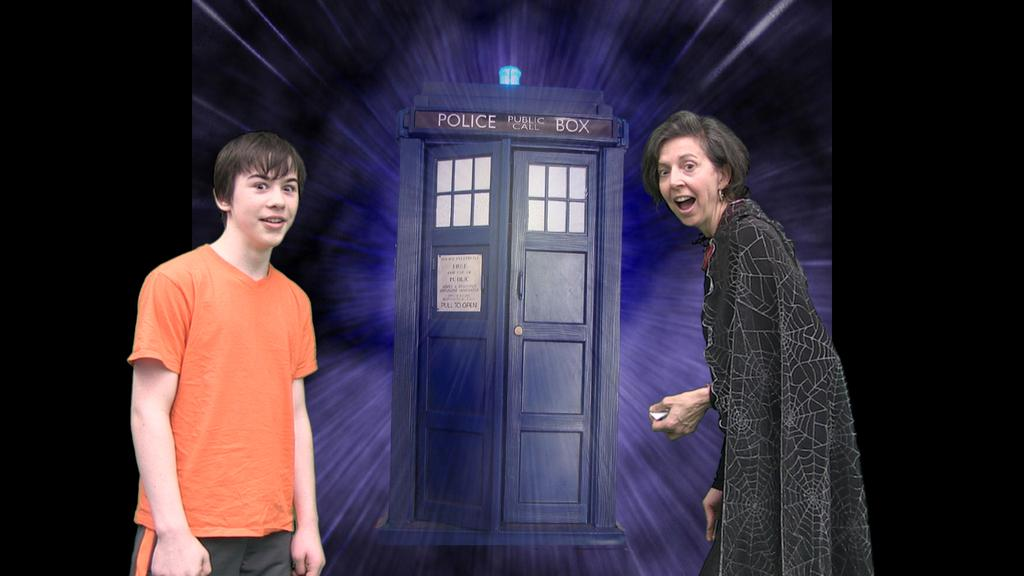How many people are in the image? There are two persons standing in the image. Can you describe the background of the image? The background of the image looks like a board. What type of butter is being used in the image? There is no butter present in the image. What kind of prose can be heard in the background of the image? There is no audio or spoken prose in the image. 